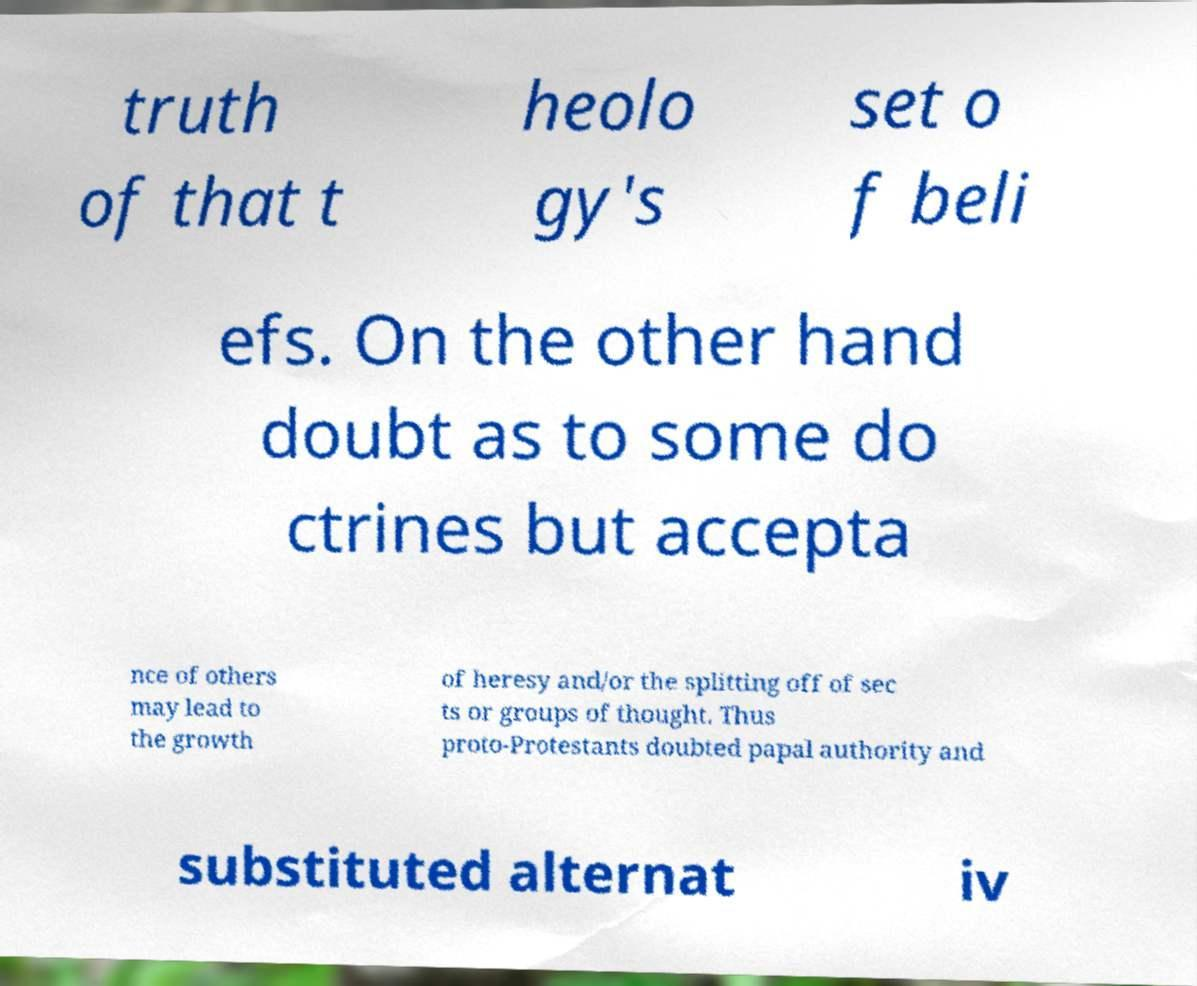There's text embedded in this image that I need extracted. Can you transcribe it verbatim? truth of that t heolo gy's set o f beli efs. On the other hand doubt as to some do ctrines but accepta nce of others may lead to the growth of heresy and/or the splitting off of sec ts or groups of thought. Thus proto-Protestants doubted papal authority and substituted alternat iv 